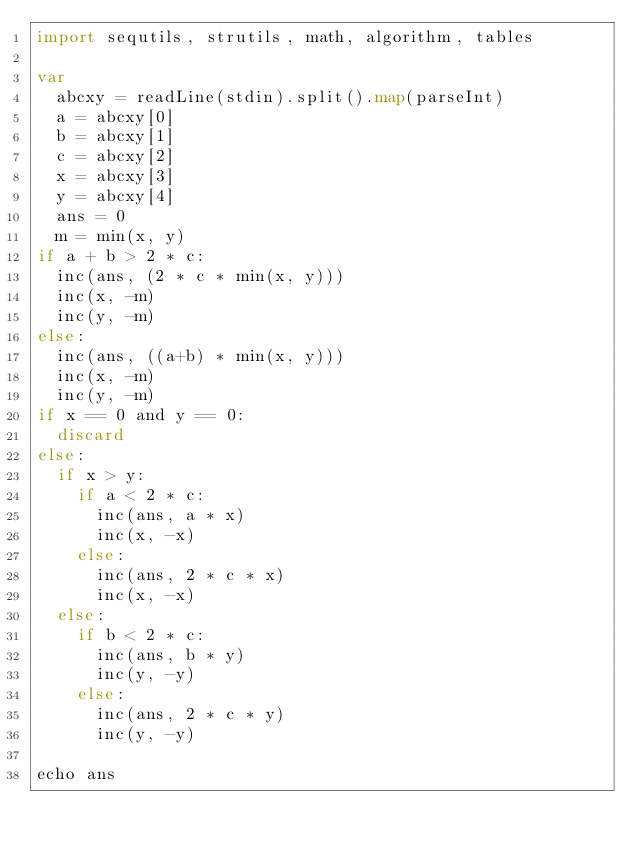<code> <loc_0><loc_0><loc_500><loc_500><_Nim_>import sequtils, strutils, math, algorithm, tables

var
  abcxy = readLine(stdin).split().map(parseInt)
  a = abcxy[0]
  b = abcxy[1]
  c = abcxy[2]
  x = abcxy[3]
  y = abcxy[4]
  ans = 0
  m = min(x, y)
if a + b > 2 * c:
  inc(ans, (2 * c * min(x, y)))
  inc(x, -m)
  inc(y, -m)
else:
  inc(ans, ((a+b) * min(x, y)))
  inc(x, -m)
  inc(y, -m)
if x == 0 and y == 0:
  discard
else:
  if x > y:
    if a < 2 * c:
      inc(ans, a * x)
      inc(x, -x)
    else:
      inc(ans, 2 * c * x)
      inc(x, -x)
  else:
    if b < 2 * c:
      inc(ans, b * y)
      inc(y, -y)
    else:
      inc(ans, 2 * c * y)
      inc(y, -y)

echo ans</code> 